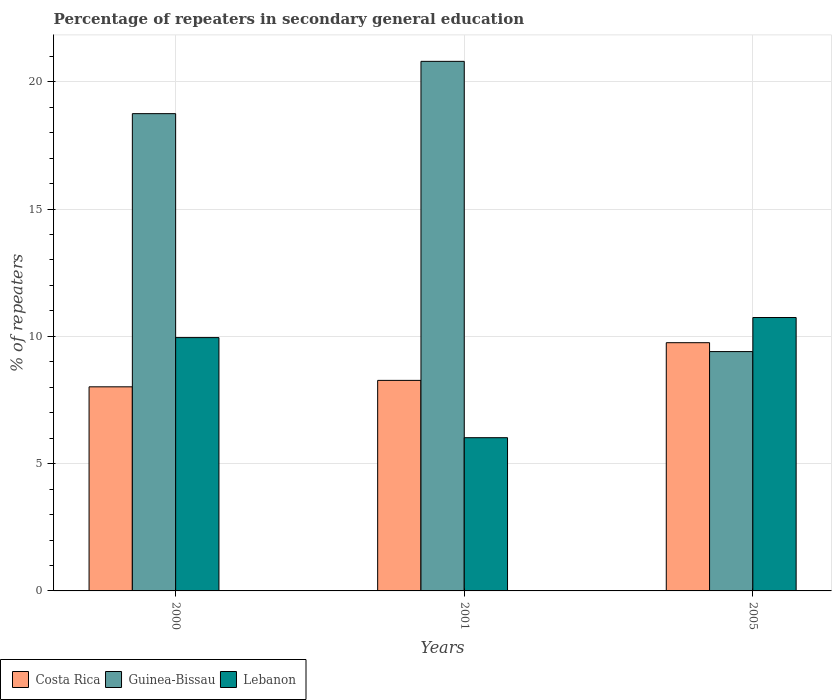How many different coloured bars are there?
Provide a short and direct response. 3. How many groups of bars are there?
Keep it short and to the point. 3. Are the number of bars on each tick of the X-axis equal?
Ensure brevity in your answer.  Yes. What is the percentage of repeaters in secondary general education in Guinea-Bissau in 2001?
Provide a short and direct response. 20.8. Across all years, what is the maximum percentage of repeaters in secondary general education in Lebanon?
Provide a short and direct response. 10.74. Across all years, what is the minimum percentage of repeaters in secondary general education in Guinea-Bissau?
Your answer should be very brief. 9.4. What is the total percentage of repeaters in secondary general education in Guinea-Bissau in the graph?
Make the answer very short. 48.95. What is the difference between the percentage of repeaters in secondary general education in Lebanon in 2000 and that in 2005?
Your answer should be compact. -0.79. What is the difference between the percentage of repeaters in secondary general education in Guinea-Bissau in 2000 and the percentage of repeaters in secondary general education in Costa Rica in 2001?
Your response must be concise. 10.48. What is the average percentage of repeaters in secondary general education in Guinea-Bissau per year?
Your answer should be compact. 16.32. In the year 2001, what is the difference between the percentage of repeaters in secondary general education in Costa Rica and percentage of repeaters in secondary general education in Guinea-Bissau?
Offer a very short reply. -12.53. In how many years, is the percentage of repeaters in secondary general education in Lebanon greater than 9 %?
Provide a short and direct response. 2. What is the ratio of the percentage of repeaters in secondary general education in Costa Rica in 2000 to that in 2001?
Make the answer very short. 0.97. Is the percentage of repeaters in secondary general education in Guinea-Bissau in 2000 less than that in 2005?
Your answer should be compact. No. What is the difference between the highest and the second highest percentage of repeaters in secondary general education in Costa Rica?
Offer a very short reply. 1.48. What is the difference between the highest and the lowest percentage of repeaters in secondary general education in Lebanon?
Your response must be concise. 4.72. What does the 2nd bar from the left in 2000 represents?
Make the answer very short. Guinea-Bissau. What does the 3rd bar from the right in 2001 represents?
Keep it short and to the point. Costa Rica. How many bars are there?
Your answer should be very brief. 9. Are all the bars in the graph horizontal?
Offer a very short reply. No. Does the graph contain any zero values?
Make the answer very short. No. How many legend labels are there?
Offer a very short reply. 3. How are the legend labels stacked?
Your answer should be compact. Horizontal. What is the title of the graph?
Keep it short and to the point. Percentage of repeaters in secondary general education. What is the label or title of the Y-axis?
Offer a very short reply. % of repeaters. What is the % of repeaters of Costa Rica in 2000?
Offer a very short reply. 8.02. What is the % of repeaters of Guinea-Bissau in 2000?
Offer a terse response. 18.75. What is the % of repeaters of Lebanon in 2000?
Make the answer very short. 9.95. What is the % of repeaters in Costa Rica in 2001?
Offer a terse response. 8.27. What is the % of repeaters in Guinea-Bissau in 2001?
Your answer should be compact. 20.8. What is the % of repeaters of Lebanon in 2001?
Your answer should be very brief. 6.02. What is the % of repeaters in Costa Rica in 2005?
Provide a succinct answer. 9.75. What is the % of repeaters in Guinea-Bissau in 2005?
Provide a succinct answer. 9.4. What is the % of repeaters in Lebanon in 2005?
Give a very brief answer. 10.74. Across all years, what is the maximum % of repeaters in Costa Rica?
Your answer should be compact. 9.75. Across all years, what is the maximum % of repeaters of Guinea-Bissau?
Your response must be concise. 20.8. Across all years, what is the maximum % of repeaters in Lebanon?
Make the answer very short. 10.74. Across all years, what is the minimum % of repeaters in Costa Rica?
Keep it short and to the point. 8.02. Across all years, what is the minimum % of repeaters in Guinea-Bissau?
Make the answer very short. 9.4. Across all years, what is the minimum % of repeaters in Lebanon?
Ensure brevity in your answer.  6.02. What is the total % of repeaters of Costa Rica in the graph?
Offer a terse response. 26.04. What is the total % of repeaters of Guinea-Bissau in the graph?
Your answer should be very brief. 48.95. What is the total % of repeaters in Lebanon in the graph?
Keep it short and to the point. 26.71. What is the difference between the % of repeaters of Costa Rica in 2000 and that in 2001?
Provide a short and direct response. -0.25. What is the difference between the % of repeaters in Guinea-Bissau in 2000 and that in 2001?
Give a very brief answer. -2.05. What is the difference between the % of repeaters in Lebanon in 2000 and that in 2001?
Make the answer very short. 3.93. What is the difference between the % of repeaters in Costa Rica in 2000 and that in 2005?
Ensure brevity in your answer.  -1.73. What is the difference between the % of repeaters of Guinea-Bissau in 2000 and that in 2005?
Your answer should be compact. 9.35. What is the difference between the % of repeaters of Lebanon in 2000 and that in 2005?
Give a very brief answer. -0.79. What is the difference between the % of repeaters of Costa Rica in 2001 and that in 2005?
Provide a short and direct response. -1.48. What is the difference between the % of repeaters in Guinea-Bissau in 2001 and that in 2005?
Make the answer very short. 11.4. What is the difference between the % of repeaters in Lebanon in 2001 and that in 2005?
Give a very brief answer. -4.72. What is the difference between the % of repeaters in Costa Rica in 2000 and the % of repeaters in Guinea-Bissau in 2001?
Give a very brief answer. -12.78. What is the difference between the % of repeaters of Costa Rica in 2000 and the % of repeaters of Lebanon in 2001?
Your answer should be very brief. 2. What is the difference between the % of repeaters in Guinea-Bissau in 2000 and the % of repeaters in Lebanon in 2001?
Make the answer very short. 12.73. What is the difference between the % of repeaters of Costa Rica in 2000 and the % of repeaters of Guinea-Bissau in 2005?
Your answer should be very brief. -1.38. What is the difference between the % of repeaters in Costa Rica in 2000 and the % of repeaters in Lebanon in 2005?
Your answer should be very brief. -2.72. What is the difference between the % of repeaters in Guinea-Bissau in 2000 and the % of repeaters in Lebanon in 2005?
Keep it short and to the point. 8.01. What is the difference between the % of repeaters in Costa Rica in 2001 and the % of repeaters in Guinea-Bissau in 2005?
Make the answer very short. -1.13. What is the difference between the % of repeaters in Costa Rica in 2001 and the % of repeaters in Lebanon in 2005?
Ensure brevity in your answer.  -2.47. What is the difference between the % of repeaters of Guinea-Bissau in 2001 and the % of repeaters of Lebanon in 2005?
Make the answer very short. 10.06. What is the average % of repeaters of Costa Rica per year?
Make the answer very short. 8.68. What is the average % of repeaters in Guinea-Bissau per year?
Your answer should be very brief. 16.32. What is the average % of repeaters in Lebanon per year?
Offer a very short reply. 8.9. In the year 2000, what is the difference between the % of repeaters in Costa Rica and % of repeaters in Guinea-Bissau?
Offer a terse response. -10.73. In the year 2000, what is the difference between the % of repeaters of Costa Rica and % of repeaters of Lebanon?
Provide a short and direct response. -1.93. In the year 2000, what is the difference between the % of repeaters of Guinea-Bissau and % of repeaters of Lebanon?
Your answer should be very brief. 8.8. In the year 2001, what is the difference between the % of repeaters in Costa Rica and % of repeaters in Guinea-Bissau?
Your response must be concise. -12.53. In the year 2001, what is the difference between the % of repeaters in Costa Rica and % of repeaters in Lebanon?
Provide a succinct answer. 2.25. In the year 2001, what is the difference between the % of repeaters in Guinea-Bissau and % of repeaters in Lebanon?
Your response must be concise. 14.78. In the year 2005, what is the difference between the % of repeaters of Costa Rica and % of repeaters of Guinea-Bissau?
Keep it short and to the point. 0.35. In the year 2005, what is the difference between the % of repeaters of Costa Rica and % of repeaters of Lebanon?
Your response must be concise. -0.99. In the year 2005, what is the difference between the % of repeaters in Guinea-Bissau and % of repeaters in Lebanon?
Offer a very short reply. -1.34. What is the ratio of the % of repeaters of Costa Rica in 2000 to that in 2001?
Your response must be concise. 0.97. What is the ratio of the % of repeaters in Guinea-Bissau in 2000 to that in 2001?
Your answer should be compact. 0.9. What is the ratio of the % of repeaters in Lebanon in 2000 to that in 2001?
Ensure brevity in your answer.  1.65. What is the ratio of the % of repeaters in Costa Rica in 2000 to that in 2005?
Your answer should be very brief. 0.82. What is the ratio of the % of repeaters of Guinea-Bissau in 2000 to that in 2005?
Your answer should be very brief. 1.99. What is the ratio of the % of repeaters of Lebanon in 2000 to that in 2005?
Provide a short and direct response. 0.93. What is the ratio of the % of repeaters of Costa Rica in 2001 to that in 2005?
Offer a terse response. 0.85. What is the ratio of the % of repeaters in Guinea-Bissau in 2001 to that in 2005?
Give a very brief answer. 2.21. What is the ratio of the % of repeaters in Lebanon in 2001 to that in 2005?
Offer a very short reply. 0.56. What is the difference between the highest and the second highest % of repeaters in Costa Rica?
Ensure brevity in your answer.  1.48. What is the difference between the highest and the second highest % of repeaters in Guinea-Bissau?
Keep it short and to the point. 2.05. What is the difference between the highest and the second highest % of repeaters of Lebanon?
Make the answer very short. 0.79. What is the difference between the highest and the lowest % of repeaters in Costa Rica?
Provide a short and direct response. 1.73. What is the difference between the highest and the lowest % of repeaters of Guinea-Bissau?
Offer a terse response. 11.4. What is the difference between the highest and the lowest % of repeaters of Lebanon?
Offer a very short reply. 4.72. 